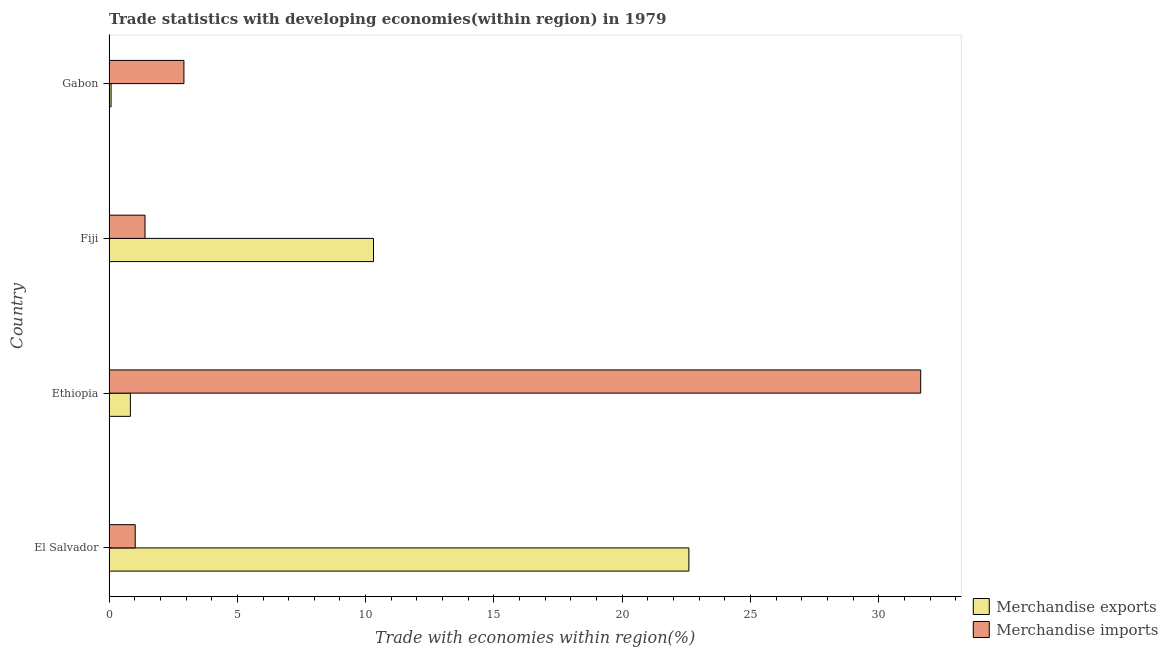How many different coloured bars are there?
Make the answer very short. 2. How many groups of bars are there?
Your answer should be compact. 4. Are the number of bars per tick equal to the number of legend labels?
Ensure brevity in your answer.  Yes. Are the number of bars on each tick of the Y-axis equal?
Offer a terse response. Yes. What is the label of the 3rd group of bars from the top?
Ensure brevity in your answer.  Ethiopia. In how many cases, is the number of bars for a given country not equal to the number of legend labels?
Your answer should be very brief. 0. What is the merchandise imports in Gabon?
Your answer should be compact. 2.92. Across all countries, what is the maximum merchandise imports?
Make the answer very short. 31.63. Across all countries, what is the minimum merchandise imports?
Give a very brief answer. 1.02. In which country was the merchandise imports maximum?
Offer a very short reply. Ethiopia. In which country was the merchandise imports minimum?
Ensure brevity in your answer.  El Salvador. What is the total merchandise imports in the graph?
Keep it short and to the point. 36.97. What is the difference between the merchandise exports in El Salvador and that in Fiji?
Provide a short and direct response. 12.29. What is the difference between the merchandise exports in Fiji and the merchandise imports in Gabon?
Provide a short and direct response. 7.39. What is the average merchandise exports per country?
Ensure brevity in your answer.  8.45. What is the difference between the merchandise imports and merchandise exports in Fiji?
Your answer should be very brief. -8.9. In how many countries, is the merchandise imports greater than 22 %?
Your answer should be very brief. 1. What is the ratio of the merchandise imports in El Salvador to that in Fiji?
Offer a very short reply. 0.73. Is the merchandise imports in El Salvador less than that in Fiji?
Offer a terse response. Yes. What is the difference between the highest and the second highest merchandise exports?
Offer a very short reply. 12.29. What is the difference between the highest and the lowest merchandise exports?
Your answer should be very brief. 22.51. In how many countries, is the merchandise imports greater than the average merchandise imports taken over all countries?
Ensure brevity in your answer.  1. How many bars are there?
Your answer should be very brief. 8. Are all the bars in the graph horizontal?
Offer a terse response. Yes. How many countries are there in the graph?
Offer a very short reply. 4. What is the difference between two consecutive major ticks on the X-axis?
Ensure brevity in your answer.  5. Are the values on the major ticks of X-axis written in scientific E-notation?
Your answer should be compact. No. Does the graph contain any zero values?
Offer a terse response. No. Does the graph contain grids?
Make the answer very short. No. Where does the legend appear in the graph?
Ensure brevity in your answer.  Bottom right. How many legend labels are there?
Offer a terse response. 2. How are the legend labels stacked?
Ensure brevity in your answer.  Vertical. What is the title of the graph?
Provide a short and direct response. Trade statistics with developing economies(within region) in 1979. Does "Fraud firms" appear as one of the legend labels in the graph?
Provide a succinct answer. No. What is the label or title of the X-axis?
Offer a very short reply. Trade with economies within region(%). What is the label or title of the Y-axis?
Your answer should be compact. Country. What is the Trade with economies within region(%) in Merchandise exports in El Salvador?
Offer a very short reply. 22.59. What is the Trade with economies within region(%) in Merchandise imports in El Salvador?
Keep it short and to the point. 1.02. What is the Trade with economies within region(%) of Merchandise exports in Ethiopia?
Your response must be concise. 0.83. What is the Trade with economies within region(%) in Merchandise imports in Ethiopia?
Your answer should be compact. 31.63. What is the Trade with economies within region(%) in Merchandise exports in Fiji?
Offer a very short reply. 10.31. What is the Trade with economies within region(%) of Merchandise imports in Fiji?
Give a very brief answer. 1.4. What is the Trade with economies within region(%) in Merchandise exports in Gabon?
Provide a succinct answer. 0.08. What is the Trade with economies within region(%) in Merchandise imports in Gabon?
Give a very brief answer. 2.92. Across all countries, what is the maximum Trade with economies within region(%) in Merchandise exports?
Keep it short and to the point. 22.59. Across all countries, what is the maximum Trade with economies within region(%) in Merchandise imports?
Your answer should be very brief. 31.63. Across all countries, what is the minimum Trade with economies within region(%) of Merchandise exports?
Provide a short and direct response. 0.08. Across all countries, what is the minimum Trade with economies within region(%) of Merchandise imports?
Your response must be concise. 1.02. What is the total Trade with economies within region(%) in Merchandise exports in the graph?
Your answer should be very brief. 33.81. What is the total Trade with economies within region(%) in Merchandise imports in the graph?
Your answer should be very brief. 36.97. What is the difference between the Trade with economies within region(%) in Merchandise exports in El Salvador and that in Ethiopia?
Give a very brief answer. 21.76. What is the difference between the Trade with economies within region(%) in Merchandise imports in El Salvador and that in Ethiopia?
Your answer should be compact. -30.61. What is the difference between the Trade with economies within region(%) of Merchandise exports in El Salvador and that in Fiji?
Offer a terse response. 12.29. What is the difference between the Trade with economies within region(%) in Merchandise imports in El Salvador and that in Fiji?
Provide a succinct answer. -0.38. What is the difference between the Trade with economies within region(%) in Merchandise exports in El Salvador and that in Gabon?
Keep it short and to the point. 22.51. What is the difference between the Trade with economies within region(%) in Merchandise imports in El Salvador and that in Gabon?
Keep it short and to the point. -1.9. What is the difference between the Trade with economies within region(%) of Merchandise exports in Ethiopia and that in Fiji?
Your response must be concise. -9.47. What is the difference between the Trade with economies within region(%) in Merchandise imports in Ethiopia and that in Fiji?
Your answer should be very brief. 30.22. What is the difference between the Trade with economies within region(%) of Merchandise exports in Ethiopia and that in Gabon?
Make the answer very short. 0.75. What is the difference between the Trade with economies within region(%) in Merchandise imports in Ethiopia and that in Gabon?
Give a very brief answer. 28.71. What is the difference between the Trade with economies within region(%) of Merchandise exports in Fiji and that in Gabon?
Offer a very short reply. 10.23. What is the difference between the Trade with economies within region(%) in Merchandise imports in Fiji and that in Gabon?
Your response must be concise. -1.52. What is the difference between the Trade with economies within region(%) in Merchandise exports in El Salvador and the Trade with economies within region(%) in Merchandise imports in Ethiopia?
Offer a very short reply. -9.03. What is the difference between the Trade with economies within region(%) in Merchandise exports in El Salvador and the Trade with economies within region(%) in Merchandise imports in Fiji?
Your answer should be compact. 21.19. What is the difference between the Trade with economies within region(%) in Merchandise exports in El Salvador and the Trade with economies within region(%) in Merchandise imports in Gabon?
Provide a succinct answer. 19.68. What is the difference between the Trade with economies within region(%) in Merchandise exports in Ethiopia and the Trade with economies within region(%) in Merchandise imports in Fiji?
Offer a terse response. -0.57. What is the difference between the Trade with economies within region(%) in Merchandise exports in Ethiopia and the Trade with economies within region(%) in Merchandise imports in Gabon?
Your answer should be compact. -2.09. What is the difference between the Trade with economies within region(%) of Merchandise exports in Fiji and the Trade with economies within region(%) of Merchandise imports in Gabon?
Your response must be concise. 7.39. What is the average Trade with economies within region(%) in Merchandise exports per country?
Your answer should be compact. 8.45. What is the average Trade with economies within region(%) in Merchandise imports per country?
Your answer should be very brief. 9.24. What is the difference between the Trade with economies within region(%) of Merchandise exports and Trade with economies within region(%) of Merchandise imports in El Salvador?
Provide a short and direct response. 21.57. What is the difference between the Trade with economies within region(%) of Merchandise exports and Trade with economies within region(%) of Merchandise imports in Ethiopia?
Provide a short and direct response. -30.79. What is the difference between the Trade with economies within region(%) of Merchandise exports and Trade with economies within region(%) of Merchandise imports in Fiji?
Give a very brief answer. 8.9. What is the difference between the Trade with economies within region(%) in Merchandise exports and Trade with economies within region(%) in Merchandise imports in Gabon?
Provide a short and direct response. -2.84. What is the ratio of the Trade with economies within region(%) of Merchandise exports in El Salvador to that in Ethiopia?
Provide a short and direct response. 27.12. What is the ratio of the Trade with economies within region(%) in Merchandise imports in El Salvador to that in Ethiopia?
Give a very brief answer. 0.03. What is the ratio of the Trade with economies within region(%) in Merchandise exports in El Salvador to that in Fiji?
Offer a very short reply. 2.19. What is the ratio of the Trade with economies within region(%) of Merchandise imports in El Salvador to that in Fiji?
Your answer should be very brief. 0.73. What is the ratio of the Trade with economies within region(%) in Merchandise exports in El Salvador to that in Gabon?
Ensure brevity in your answer.  280.85. What is the ratio of the Trade with economies within region(%) of Merchandise imports in El Salvador to that in Gabon?
Offer a very short reply. 0.35. What is the ratio of the Trade with economies within region(%) in Merchandise exports in Ethiopia to that in Fiji?
Ensure brevity in your answer.  0.08. What is the ratio of the Trade with economies within region(%) of Merchandise imports in Ethiopia to that in Fiji?
Provide a short and direct response. 22.54. What is the ratio of the Trade with economies within region(%) of Merchandise exports in Ethiopia to that in Gabon?
Your answer should be very brief. 10.36. What is the ratio of the Trade with economies within region(%) of Merchandise imports in Ethiopia to that in Gabon?
Ensure brevity in your answer.  10.84. What is the ratio of the Trade with economies within region(%) of Merchandise exports in Fiji to that in Gabon?
Provide a succinct answer. 128.1. What is the ratio of the Trade with economies within region(%) in Merchandise imports in Fiji to that in Gabon?
Provide a succinct answer. 0.48. What is the difference between the highest and the second highest Trade with economies within region(%) in Merchandise exports?
Provide a succinct answer. 12.29. What is the difference between the highest and the second highest Trade with economies within region(%) of Merchandise imports?
Your answer should be compact. 28.71. What is the difference between the highest and the lowest Trade with economies within region(%) of Merchandise exports?
Provide a short and direct response. 22.51. What is the difference between the highest and the lowest Trade with economies within region(%) in Merchandise imports?
Offer a terse response. 30.61. 